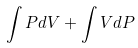<formula> <loc_0><loc_0><loc_500><loc_500>\int P d V + \int V d P</formula> 